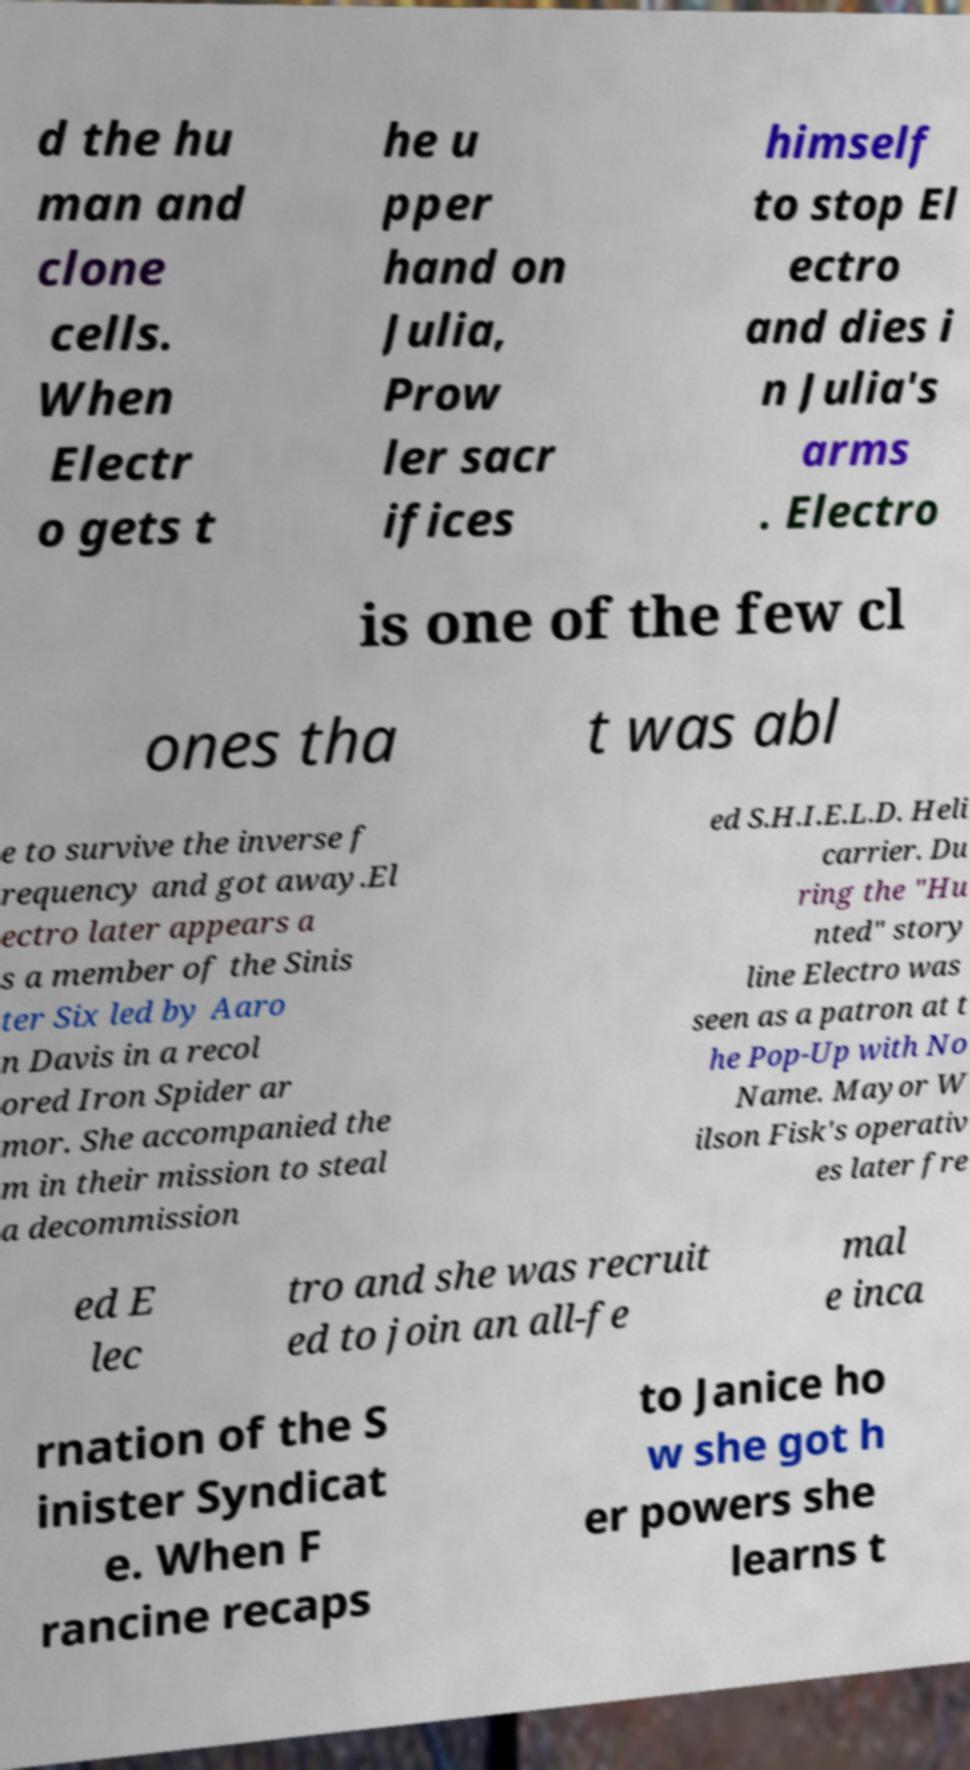Can you read and provide the text displayed in the image?This photo seems to have some interesting text. Can you extract and type it out for me? d the hu man and clone cells. When Electr o gets t he u pper hand on Julia, Prow ler sacr ifices himself to stop El ectro and dies i n Julia's arms . Electro is one of the few cl ones tha t was abl e to survive the inverse f requency and got away.El ectro later appears a s a member of the Sinis ter Six led by Aaro n Davis in a recol ored Iron Spider ar mor. She accompanied the m in their mission to steal a decommission ed S.H.I.E.L.D. Heli carrier. Du ring the "Hu nted" story line Electro was seen as a patron at t he Pop-Up with No Name. Mayor W ilson Fisk's operativ es later fre ed E lec tro and she was recruit ed to join an all-fe mal e inca rnation of the S inister Syndicat e. When F rancine recaps to Janice ho w she got h er powers she learns t 